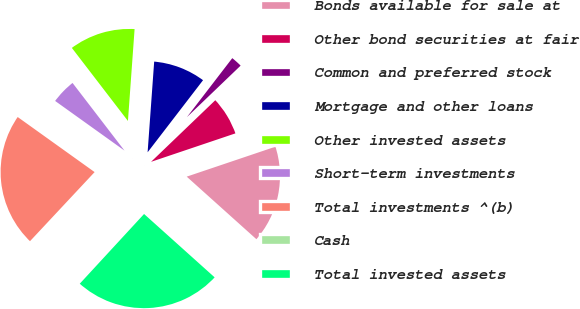<chart> <loc_0><loc_0><loc_500><loc_500><pie_chart><fcel>Bonds available for sale at<fcel>Other bond securities at fair<fcel>Common and preferred stock<fcel>Mortgage and other loans<fcel>Other invested assets<fcel>Short-term investments<fcel>Total investments ^(b)<fcel>Cash<fcel>Total invested assets<nl><fcel>16.82%<fcel>6.99%<fcel>2.4%<fcel>9.28%<fcel>11.57%<fcel>4.69%<fcel>22.92%<fcel>0.11%<fcel>25.21%<nl></chart> 